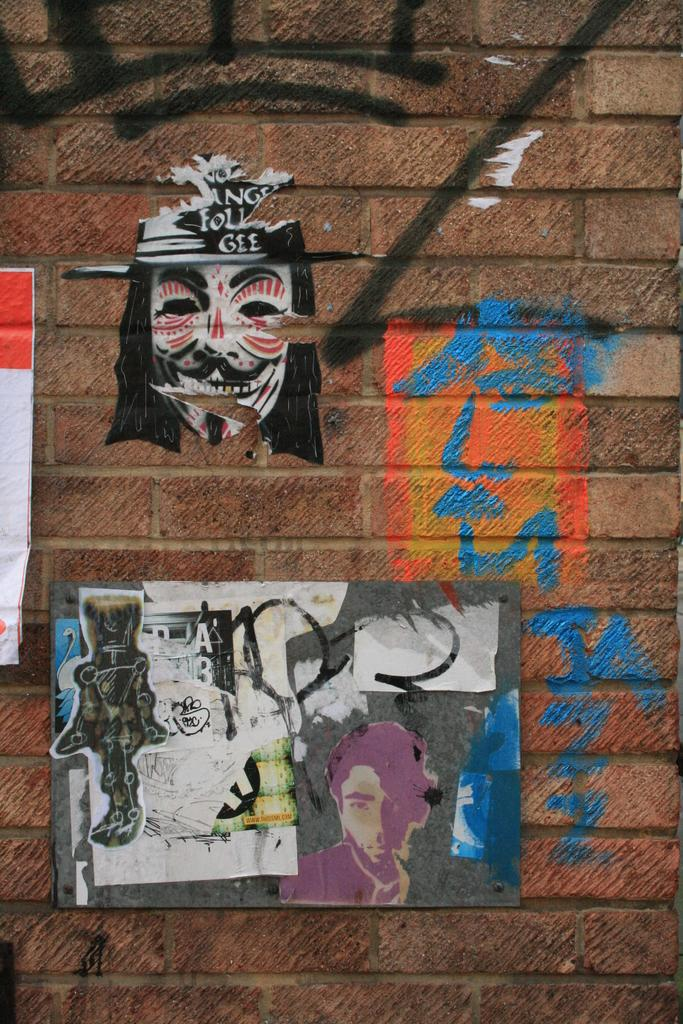What is depicted on the wall in the image? There are paintings on the wall in the image. How many ministers are present in the image? There are no ministers present in the image; it only features paintings on the wall. What type of boundary can be seen in the image? There is no boundary visible in the image; it only shows paintings on the wall. 